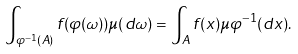<formula> <loc_0><loc_0><loc_500><loc_500>\int _ { \varphi ^ { - 1 } ( A ) } f ( \varphi ( \omega ) ) \mu ( d \omega ) = \int _ { A } f ( x ) \mu \varphi ^ { - 1 } ( d x ) .</formula> 